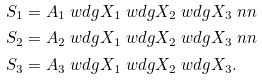Convert formula to latex. <formula><loc_0><loc_0><loc_500><loc_500>S _ { 1 } & = A _ { 1 } \ w d g X _ { 1 } \ w d g X _ { 2 } \ w d g X _ { 3 } \ n n \\ S _ { 2 } & = A _ { 2 } \ w d g X _ { 1 } \ w d g X _ { 2 } \ w d g X _ { 3 } \ n n \\ S _ { 3 } & = A _ { 3 } \ w d g X _ { 1 } \ w d g X _ { 2 } \ w d g X _ { 3 } .</formula> 